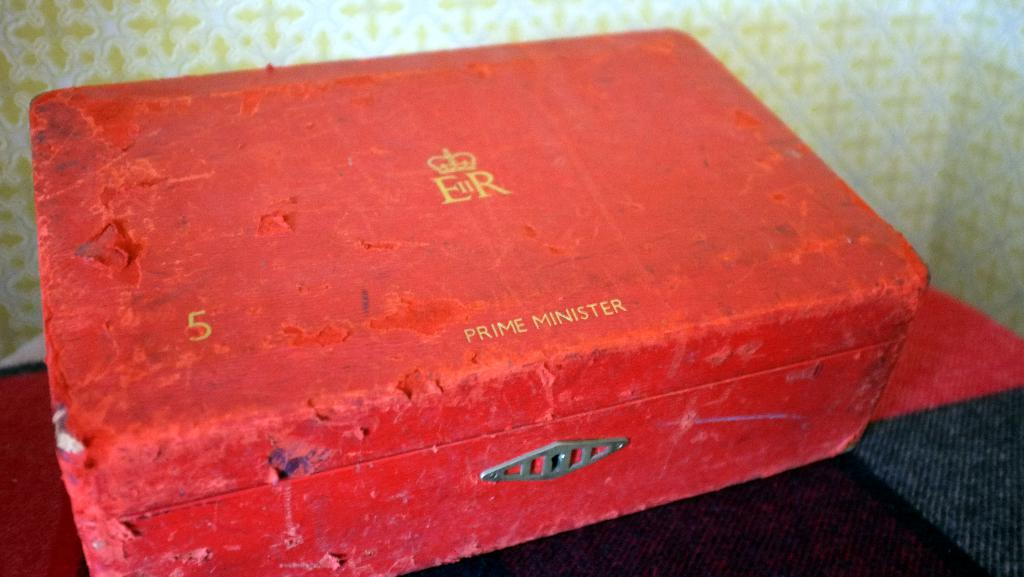<image>
Describe the image concisely. A red box that has a logo with the letters "ER" and it also says "Prime Minister". 